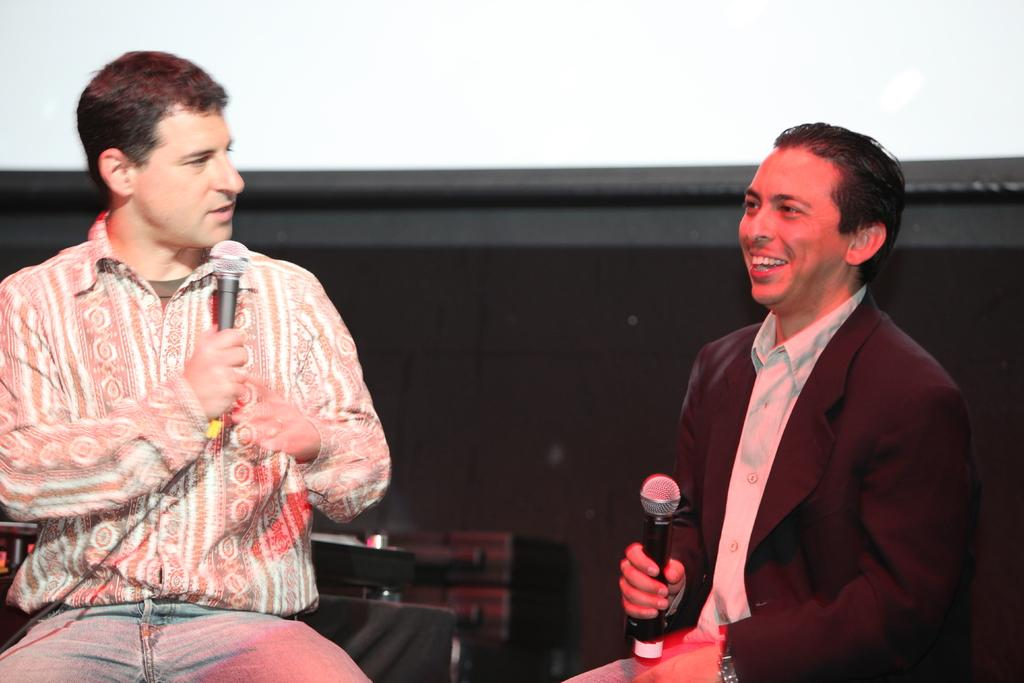How many people are in the room in the image? There are two persons in the room. What are the two persons doing in the image? The two persons are sitting on chairs, and they may be talking to each other. What objects are the two persons holding in the image? Both persons are holding microphones. What is the texture of the screw on the table in the image? There is no screw present in the image. 